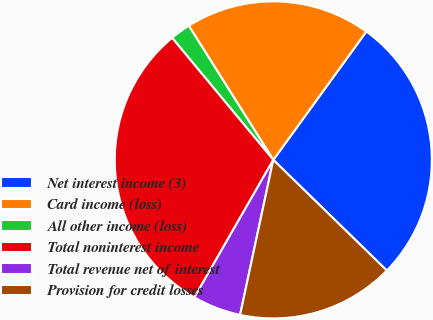<chart> <loc_0><loc_0><loc_500><loc_500><pie_chart><fcel>Net interest income (3)<fcel>Card income (loss)<fcel>All other income (loss)<fcel>Total noninterest income<fcel>Total revenue net of interest<fcel>Provision for credit losses<nl><fcel>27.31%<fcel>18.93%<fcel>2.07%<fcel>30.69%<fcel>4.93%<fcel>16.06%<nl></chart> 